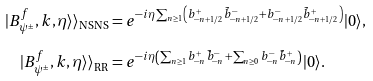Convert formula to latex. <formula><loc_0><loc_0><loc_500><loc_500>| B _ { \psi ^ { \pm } } ^ { f } , k , \eta \rangle \rangle _ { \text {NSNS} } & = e ^ { - i \eta \sum _ { n \geq 1 } \left ( b ^ { + } _ { - n + 1 / 2 } \tilde { b } ^ { - } _ { - n + 1 / 2 } + b ^ { - } _ { - n + 1 / 2 } \tilde { b } ^ { + } _ { - n + 1 / 2 } \right ) } | 0 \rangle , \\ | B _ { \psi ^ { \pm } } ^ { f } , k , \eta \rangle \rangle _ { \text {RR} } & = e ^ { - i \eta \left ( \sum _ { n \geq 1 } b ^ { + } _ { - n } \tilde { b } ^ { - } _ { - n } + \sum _ { n \geq 0 } b ^ { - } _ { - n } \tilde { b } ^ { + } _ { - n } \right ) } | 0 \rangle .</formula> 